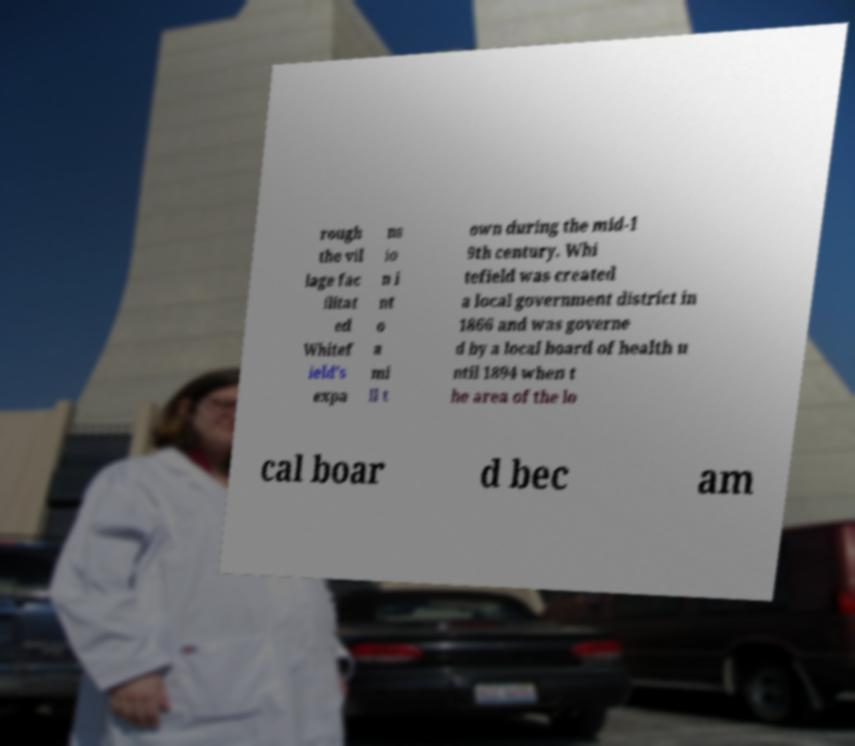For documentation purposes, I need the text within this image transcribed. Could you provide that? rough the vil lage fac ilitat ed Whitef ield's expa ns io n i nt o a mi ll t own during the mid-1 9th century. Whi tefield was created a local government district in 1866 and was governe d by a local board of health u ntil 1894 when t he area of the lo cal boar d bec am 